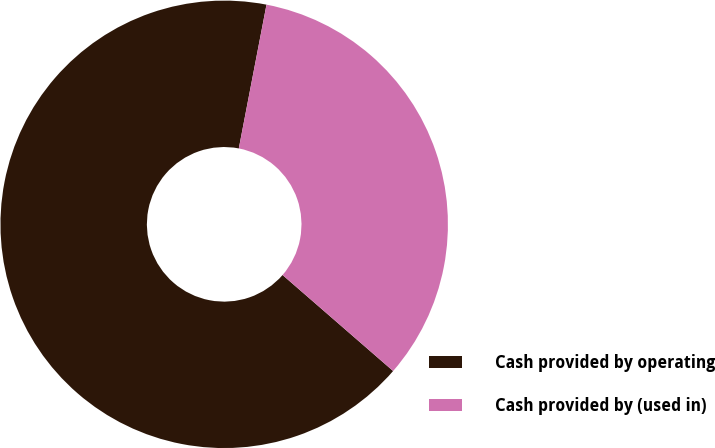Convert chart. <chart><loc_0><loc_0><loc_500><loc_500><pie_chart><fcel>Cash provided by operating<fcel>Cash provided by (used in)<nl><fcel>66.65%<fcel>33.35%<nl></chart> 